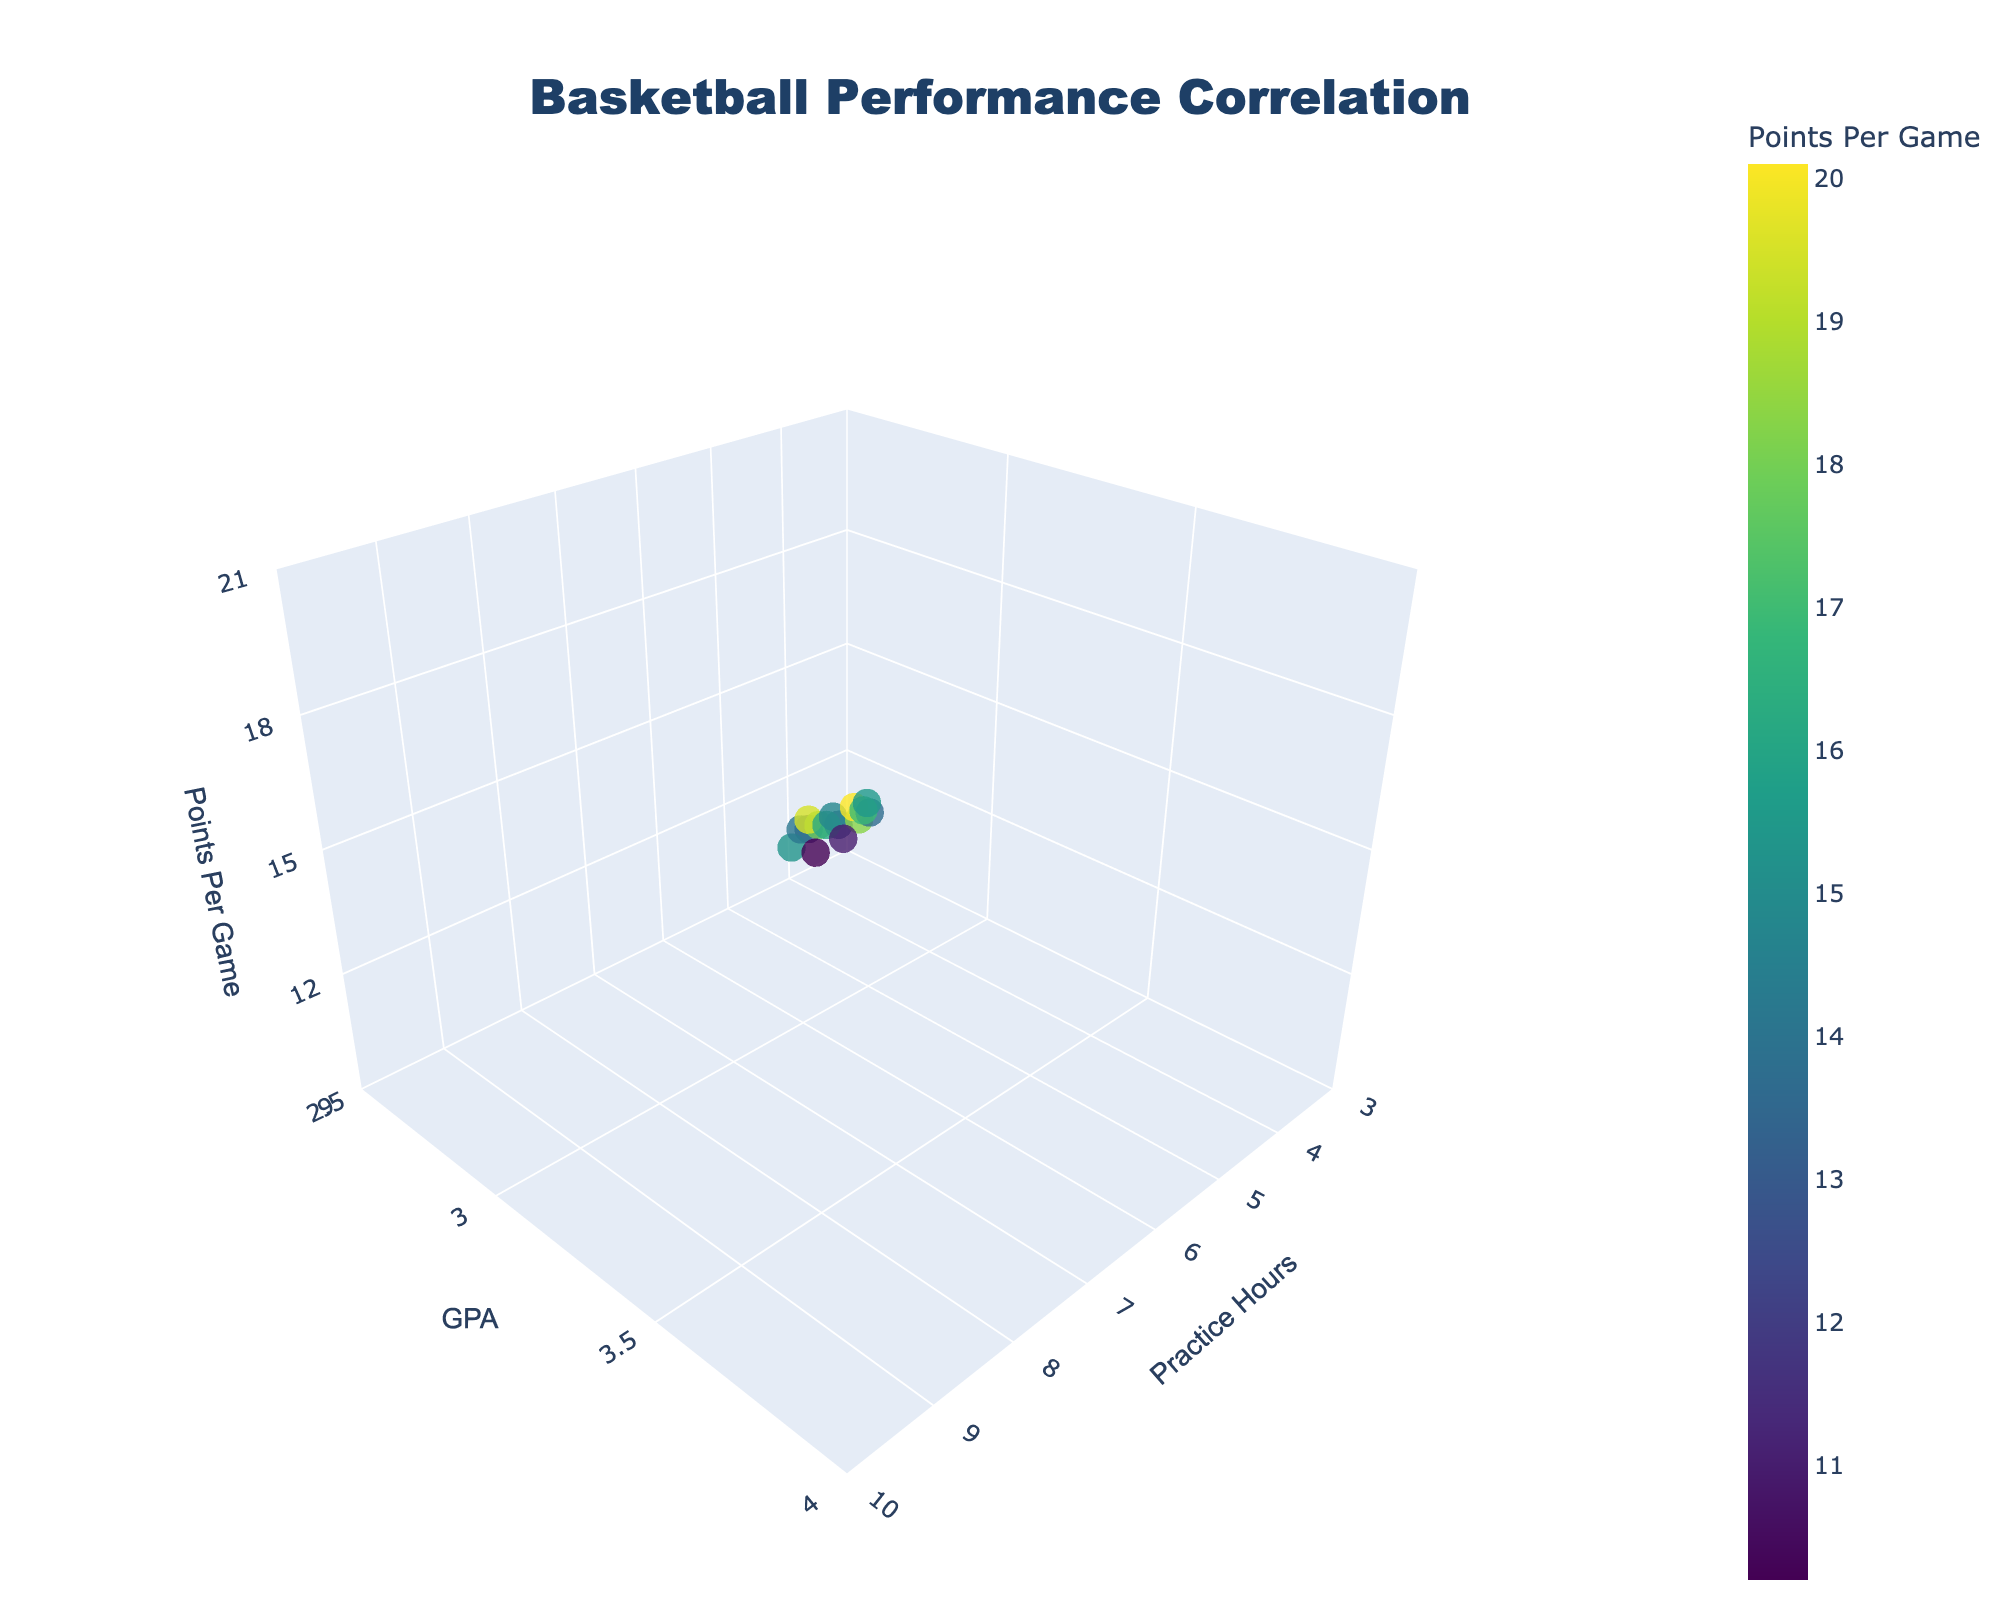What is the title of the 3D plot? The title is displayed at the top center of the plot. It reads "Basketball Performance Correlation."
Answer: Basketball Performance Correlation What are the three axes labeled in the 3D plot? The plot has three axes with labels: "Practice Hours" on the x-axis, "GPA" on the y-axis, and "Points Per Game" on the z-axis.
Answer: Practice Hours, GPA, and Points Per Game How many data points are plotted in the figure? By counting the discrete markers in the plot, you can see that there are 15 data points represented.
Answer: 15 What is the range of GPA values in the plot? The GPA values range from 2.5 to 4.0 as shown on the y-axis.
Answer: 2.5 to 4.0 What is the relationship between practice hours and GPA based on visual inspection? By observing the plot, there appears to be a positive correlation between practice hours and GPA, where more practice hours tend to correspond with higher GPAs.
Answer: Positive correlation Which data point has the highest Points Per Game? The data point with the highest Points Per Game is identified by looking at the maximum z-axis value, which is 20.1, occurring at the practice hour of 9 and GPA of 3.8.
Answer: Practice: 9 hours, GPA: 3.8, PPG: 20.1 Is there any data point where a player practices more than 8 hours but scores less than 15 points per game? Look at the data points where the practice hours are greater than 8, and then check their Points Per Game. There are none that score less than 15 points per game.
Answer: No On average, what is the Points Per Game for players who practice 7 hours? There are three data points with 7 practice hours. Calculating the average: (15.3 + 16.2 + 16.9) / 3 = 16.13
Answer: 16.13 What general trend can be observed regarding the number of practice hours and Points Per Game? The plot shows a general trend where more practice hours often result in higher Points Per Game.
Answer: More practice hours, higher PPG Describe the color scheme of the markers in the 3D plot. The data points are colored using a Viridis color scale, where the color intensity varies based on the Points Per Game.
Answer: Viridis color scale 